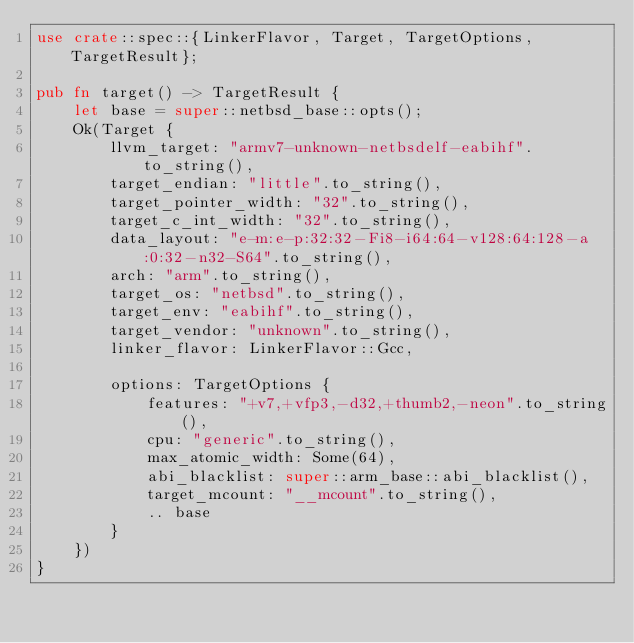<code> <loc_0><loc_0><loc_500><loc_500><_Rust_>use crate::spec::{LinkerFlavor, Target, TargetOptions, TargetResult};

pub fn target() -> TargetResult {
    let base = super::netbsd_base::opts();
    Ok(Target {
        llvm_target: "armv7-unknown-netbsdelf-eabihf".to_string(),
        target_endian: "little".to_string(),
        target_pointer_width: "32".to_string(),
        target_c_int_width: "32".to_string(),
        data_layout: "e-m:e-p:32:32-Fi8-i64:64-v128:64:128-a:0:32-n32-S64".to_string(),
        arch: "arm".to_string(),
        target_os: "netbsd".to_string(),
        target_env: "eabihf".to_string(),
        target_vendor: "unknown".to_string(),
        linker_flavor: LinkerFlavor::Gcc,

        options: TargetOptions {
            features: "+v7,+vfp3,-d32,+thumb2,-neon".to_string(),
            cpu: "generic".to_string(),
            max_atomic_width: Some(64),
            abi_blacklist: super::arm_base::abi_blacklist(),
            target_mcount: "__mcount".to_string(),
            .. base
        }
    })
}
</code> 